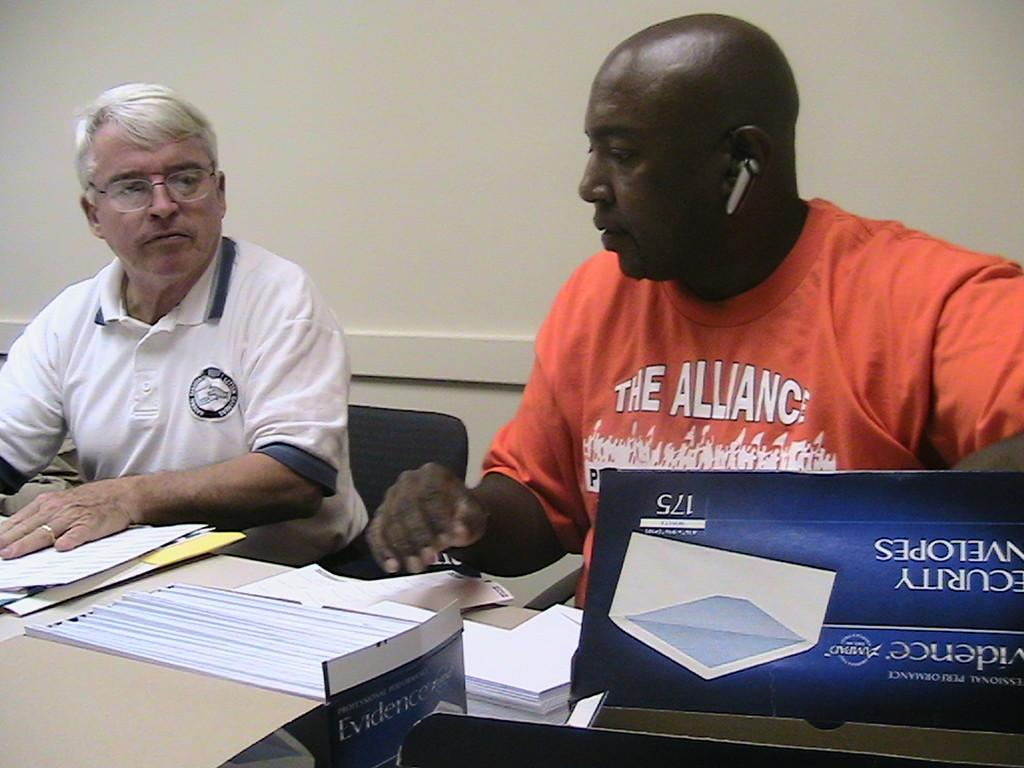Who or what can be seen in the image? There are people in the image. What objects are present in the image besides the people? There are cardboard boxes and posters in the image. What type of background can be seen in the image? There is a wall in the image. Where is the cactus located in the image? There is no cactus present in the image. 